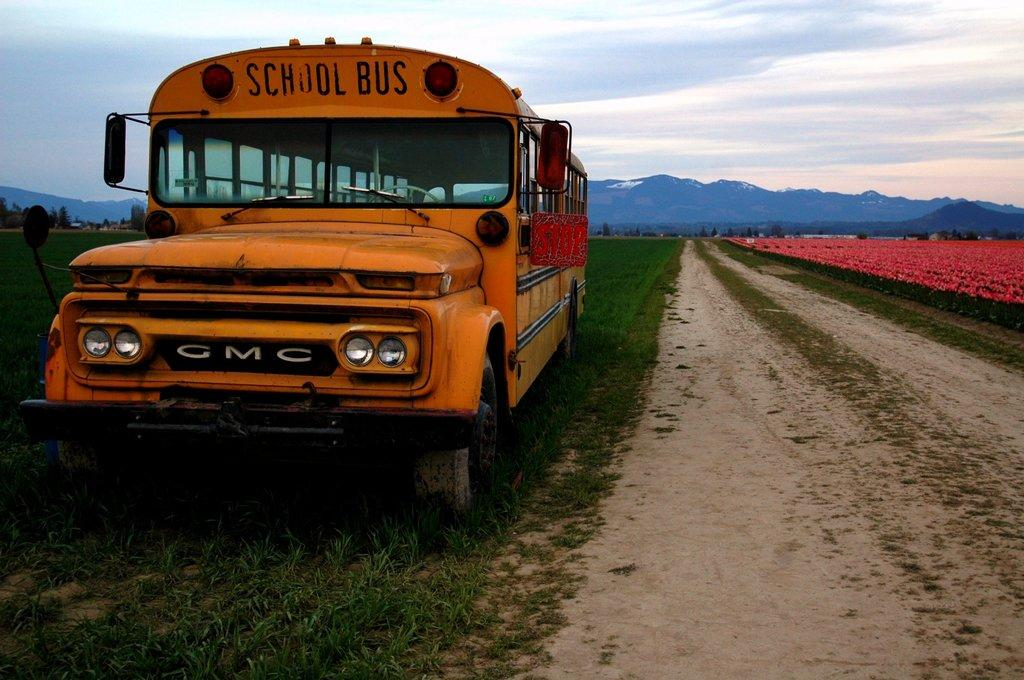What is located on the grass in the image? There is a vehicle on the grass in the image. What type of vegetation can be seen near the plants in the image? There are flowers near the plants in the image. What other natural elements are visible in the image? There are trees visible in the image. What time does the clock show in the image? There is no clock present in the image. What type of stem is visible on the flowers in the image? The flowers in the image do not have stems visible. 